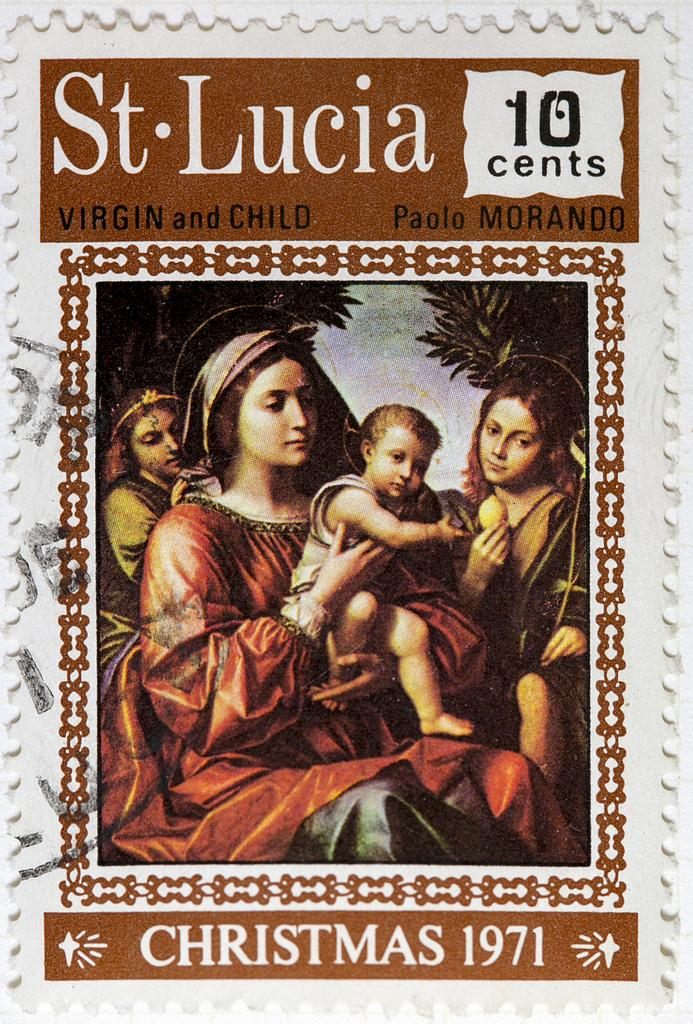What is present at the top and bottom of the image? The image contains text at the top and bottom. What is the woman in the image doing? The woman is holding a kid in the image. How many other people are in the image besides the woman and the kid? There are two other people in the image. What can be seen in the foreground of the image? Trees are present in the foreground of the image. What language is the spy speaking in the image? There is no spy present in the image, and therefore no language can be attributed to them. 